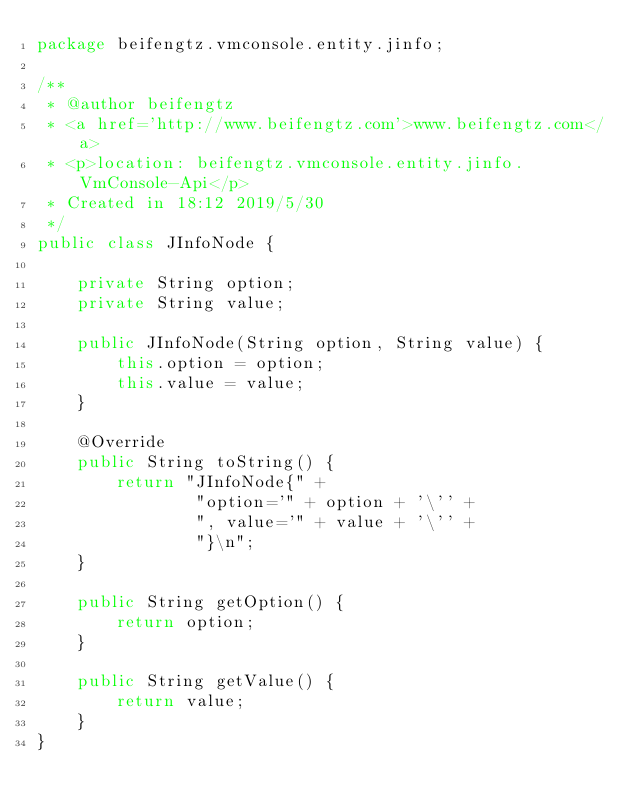Convert code to text. <code><loc_0><loc_0><loc_500><loc_500><_Java_>package beifengtz.vmconsole.entity.jinfo;

/**
 * @author beifengtz
 * <a href='http://www.beifengtz.com'>www.beifengtz.com</a>
 * <p>location: beifengtz.vmconsole.entity.jinfo.VmConsole-Api</p>
 * Created in 18:12 2019/5/30
 */
public class JInfoNode {

    private String option;
    private String value;

    public JInfoNode(String option, String value) {
        this.option = option;
        this.value = value;
    }

    @Override
    public String toString() {
        return "JInfoNode{" +
                "option='" + option + '\'' +
                ", value='" + value + '\'' +
                "}\n";
    }

    public String getOption() {
        return option;
    }

    public String getValue() {
        return value;
    }
}
</code> 